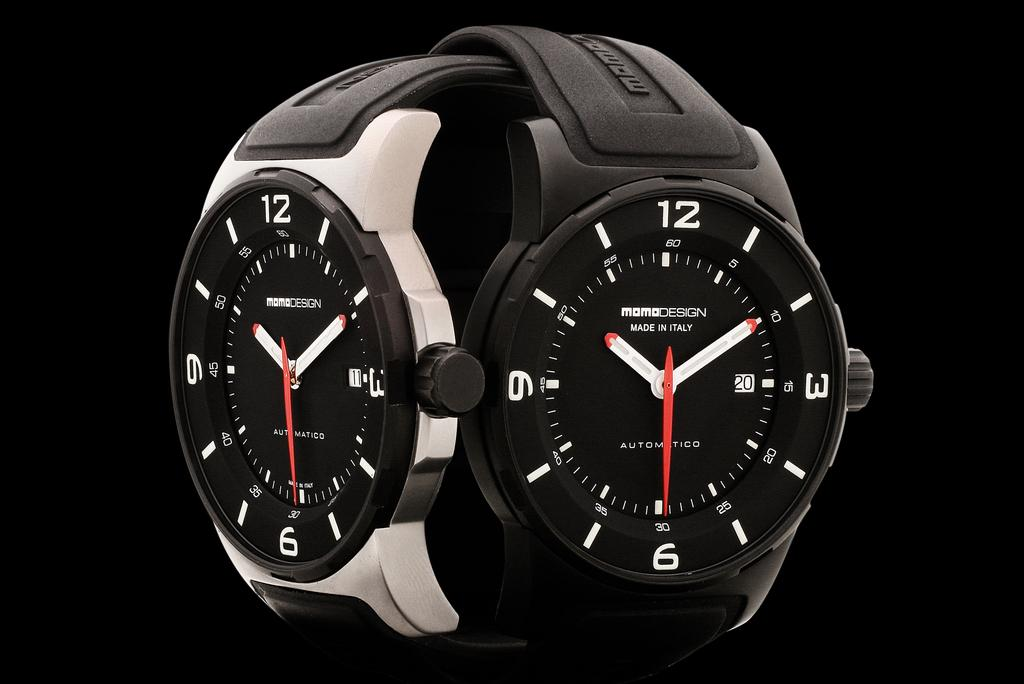<image>
Write a terse but informative summary of the picture. A momo design wrist watch is made in Italy. 